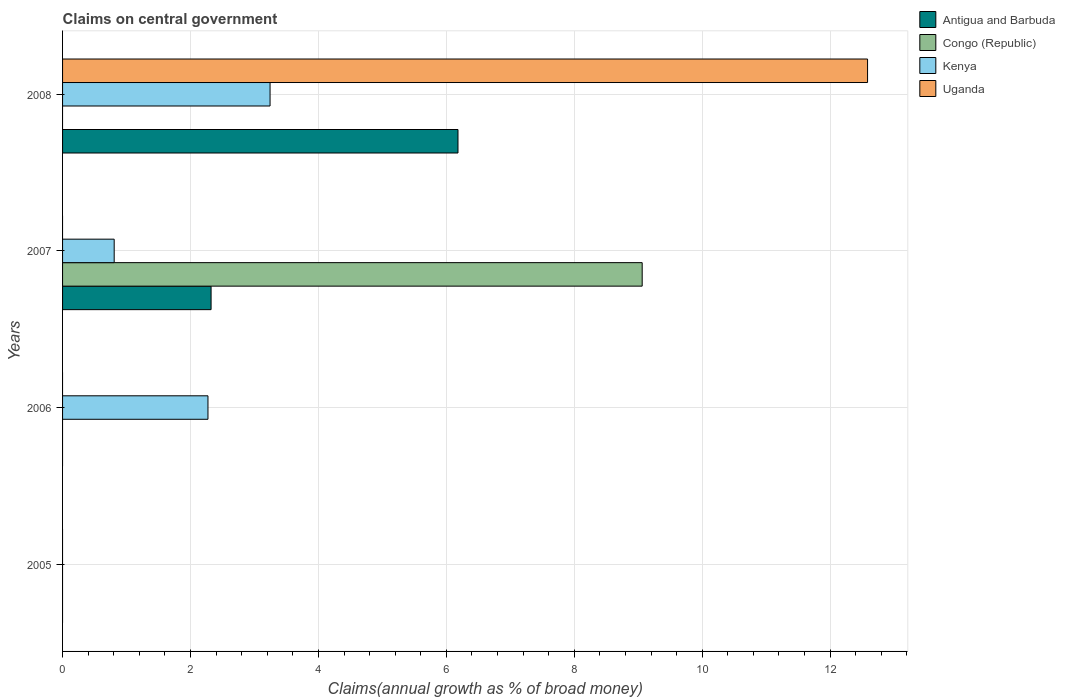How many different coloured bars are there?
Your response must be concise. 4. Are the number of bars on each tick of the Y-axis equal?
Offer a terse response. No. How many bars are there on the 1st tick from the top?
Provide a short and direct response. 3. How many bars are there on the 4th tick from the bottom?
Make the answer very short. 3. In how many cases, is the number of bars for a given year not equal to the number of legend labels?
Provide a succinct answer. 4. Across all years, what is the maximum percentage of broad money claimed on centeral government in Antigua and Barbuda?
Your response must be concise. 6.18. Across all years, what is the minimum percentage of broad money claimed on centeral government in Congo (Republic)?
Ensure brevity in your answer.  0. In which year was the percentage of broad money claimed on centeral government in Congo (Republic) maximum?
Your answer should be very brief. 2007. What is the total percentage of broad money claimed on centeral government in Kenya in the graph?
Your answer should be very brief. 6.32. What is the difference between the percentage of broad money claimed on centeral government in Kenya in 2006 and that in 2007?
Provide a short and direct response. 1.47. What is the difference between the percentage of broad money claimed on centeral government in Antigua and Barbuda in 2005 and the percentage of broad money claimed on centeral government in Uganda in 2007?
Provide a short and direct response. 0. What is the average percentage of broad money claimed on centeral government in Kenya per year?
Your answer should be compact. 1.58. In the year 2007, what is the difference between the percentage of broad money claimed on centeral government in Antigua and Barbuda and percentage of broad money claimed on centeral government in Kenya?
Your answer should be compact. 1.51. What is the difference between the highest and the second highest percentage of broad money claimed on centeral government in Kenya?
Give a very brief answer. 0.97. What is the difference between the highest and the lowest percentage of broad money claimed on centeral government in Congo (Republic)?
Your answer should be compact. 9.06. Is the sum of the percentage of broad money claimed on centeral government in Kenya in 2007 and 2008 greater than the maximum percentage of broad money claimed on centeral government in Uganda across all years?
Offer a terse response. No. How many bars are there?
Make the answer very short. 7. Are all the bars in the graph horizontal?
Offer a very short reply. Yes. Are the values on the major ticks of X-axis written in scientific E-notation?
Ensure brevity in your answer.  No. Does the graph contain any zero values?
Provide a succinct answer. Yes. Does the graph contain grids?
Your answer should be compact. Yes. Where does the legend appear in the graph?
Offer a terse response. Top right. How are the legend labels stacked?
Your answer should be compact. Vertical. What is the title of the graph?
Your answer should be compact. Claims on central government. Does "Cyprus" appear as one of the legend labels in the graph?
Ensure brevity in your answer.  No. What is the label or title of the X-axis?
Offer a very short reply. Claims(annual growth as % of broad money). What is the label or title of the Y-axis?
Your response must be concise. Years. What is the Claims(annual growth as % of broad money) in Congo (Republic) in 2005?
Provide a succinct answer. 0. What is the Claims(annual growth as % of broad money) in Kenya in 2005?
Offer a very short reply. 0. What is the Claims(annual growth as % of broad money) in Uganda in 2005?
Give a very brief answer. 0. What is the Claims(annual growth as % of broad money) in Antigua and Barbuda in 2006?
Provide a short and direct response. 0. What is the Claims(annual growth as % of broad money) in Congo (Republic) in 2006?
Your answer should be very brief. 0. What is the Claims(annual growth as % of broad money) in Kenya in 2006?
Give a very brief answer. 2.27. What is the Claims(annual growth as % of broad money) of Uganda in 2006?
Provide a succinct answer. 0. What is the Claims(annual growth as % of broad money) of Antigua and Barbuda in 2007?
Your response must be concise. 2.32. What is the Claims(annual growth as % of broad money) in Congo (Republic) in 2007?
Ensure brevity in your answer.  9.06. What is the Claims(annual growth as % of broad money) in Kenya in 2007?
Your response must be concise. 0.81. What is the Claims(annual growth as % of broad money) of Antigua and Barbuda in 2008?
Your response must be concise. 6.18. What is the Claims(annual growth as % of broad money) of Kenya in 2008?
Offer a terse response. 3.24. What is the Claims(annual growth as % of broad money) in Uganda in 2008?
Offer a very short reply. 12.59. Across all years, what is the maximum Claims(annual growth as % of broad money) in Antigua and Barbuda?
Ensure brevity in your answer.  6.18. Across all years, what is the maximum Claims(annual growth as % of broad money) in Congo (Republic)?
Offer a very short reply. 9.06. Across all years, what is the maximum Claims(annual growth as % of broad money) in Kenya?
Your answer should be compact. 3.24. Across all years, what is the maximum Claims(annual growth as % of broad money) in Uganda?
Provide a short and direct response. 12.59. Across all years, what is the minimum Claims(annual growth as % of broad money) of Antigua and Barbuda?
Offer a very short reply. 0. Across all years, what is the minimum Claims(annual growth as % of broad money) of Kenya?
Offer a very short reply. 0. Across all years, what is the minimum Claims(annual growth as % of broad money) of Uganda?
Give a very brief answer. 0. What is the total Claims(annual growth as % of broad money) of Antigua and Barbuda in the graph?
Give a very brief answer. 8.5. What is the total Claims(annual growth as % of broad money) in Congo (Republic) in the graph?
Keep it short and to the point. 9.06. What is the total Claims(annual growth as % of broad money) of Kenya in the graph?
Offer a terse response. 6.32. What is the total Claims(annual growth as % of broad money) in Uganda in the graph?
Provide a short and direct response. 12.59. What is the difference between the Claims(annual growth as % of broad money) of Kenya in 2006 and that in 2007?
Offer a terse response. 1.47. What is the difference between the Claims(annual growth as % of broad money) of Kenya in 2006 and that in 2008?
Your answer should be compact. -0.97. What is the difference between the Claims(annual growth as % of broad money) in Antigua and Barbuda in 2007 and that in 2008?
Provide a short and direct response. -3.86. What is the difference between the Claims(annual growth as % of broad money) in Kenya in 2007 and that in 2008?
Your answer should be very brief. -2.44. What is the difference between the Claims(annual growth as % of broad money) in Kenya in 2006 and the Claims(annual growth as % of broad money) in Uganda in 2008?
Offer a very short reply. -10.31. What is the difference between the Claims(annual growth as % of broad money) in Antigua and Barbuda in 2007 and the Claims(annual growth as % of broad money) in Kenya in 2008?
Provide a succinct answer. -0.92. What is the difference between the Claims(annual growth as % of broad money) in Antigua and Barbuda in 2007 and the Claims(annual growth as % of broad money) in Uganda in 2008?
Provide a short and direct response. -10.26. What is the difference between the Claims(annual growth as % of broad money) of Congo (Republic) in 2007 and the Claims(annual growth as % of broad money) of Kenya in 2008?
Give a very brief answer. 5.82. What is the difference between the Claims(annual growth as % of broad money) in Congo (Republic) in 2007 and the Claims(annual growth as % of broad money) in Uganda in 2008?
Your response must be concise. -3.52. What is the difference between the Claims(annual growth as % of broad money) in Kenya in 2007 and the Claims(annual growth as % of broad money) in Uganda in 2008?
Make the answer very short. -11.78. What is the average Claims(annual growth as % of broad money) in Antigua and Barbuda per year?
Make the answer very short. 2.13. What is the average Claims(annual growth as % of broad money) of Congo (Republic) per year?
Keep it short and to the point. 2.27. What is the average Claims(annual growth as % of broad money) of Kenya per year?
Ensure brevity in your answer.  1.58. What is the average Claims(annual growth as % of broad money) of Uganda per year?
Offer a very short reply. 3.15. In the year 2007, what is the difference between the Claims(annual growth as % of broad money) in Antigua and Barbuda and Claims(annual growth as % of broad money) in Congo (Republic)?
Your answer should be very brief. -6.74. In the year 2007, what is the difference between the Claims(annual growth as % of broad money) in Antigua and Barbuda and Claims(annual growth as % of broad money) in Kenya?
Your response must be concise. 1.51. In the year 2007, what is the difference between the Claims(annual growth as % of broad money) in Congo (Republic) and Claims(annual growth as % of broad money) in Kenya?
Make the answer very short. 8.25. In the year 2008, what is the difference between the Claims(annual growth as % of broad money) in Antigua and Barbuda and Claims(annual growth as % of broad money) in Kenya?
Your answer should be very brief. 2.94. In the year 2008, what is the difference between the Claims(annual growth as % of broad money) of Antigua and Barbuda and Claims(annual growth as % of broad money) of Uganda?
Ensure brevity in your answer.  -6.4. In the year 2008, what is the difference between the Claims(annual growth as % of broad money) in Kenya and Claims(annual growth as % of broad money) in Uganda?
Provide a short and direct response. -9.34. What is the ratio of the Claims(annual growth as % of broad money) of Kenya in 2006 to that in 2007?
Ensure brevity in your answer.  2.82. What is the ratio of the Claims(annual growth as % of broad money) in Kenya in 2006 to that in 2008?
Your answer should be compact. 0.7. What is the ratio of the Claims(annual growth as % of broad money) in Antigua and Barbuda in 2007 to that in 2008?
Make the answer very short. 0.38. What is the ratio of the Claims(annual growth as % of broad money) in Kenya in 2007 to that in 2008?
Your answer should be very brief. 0.25. What is the difference between the highest and the second highest Claims(annual growth as % of broad money) in Kenya?
Give a very brief answer. 0.97. What is the difference between the highest and the lowest Claims(annual growth as % of broad money) of Antigua and Barbuda?
Provide a short and direct response. 6.18. What is the difference between the highest and the lowest Claims(annual growth as % of broad money) of Congo (Republic)?
Make the answer very short. 9.06. What is the difference between the highest and the lowest Claims(annual growth as % of broad money) of Kenya?
Offer a terse response. 3.24. What is the difference between the highest and the lowest Claims(annual growth as % of broad money) of Uganda?
Your response must be concise. 12.59. 